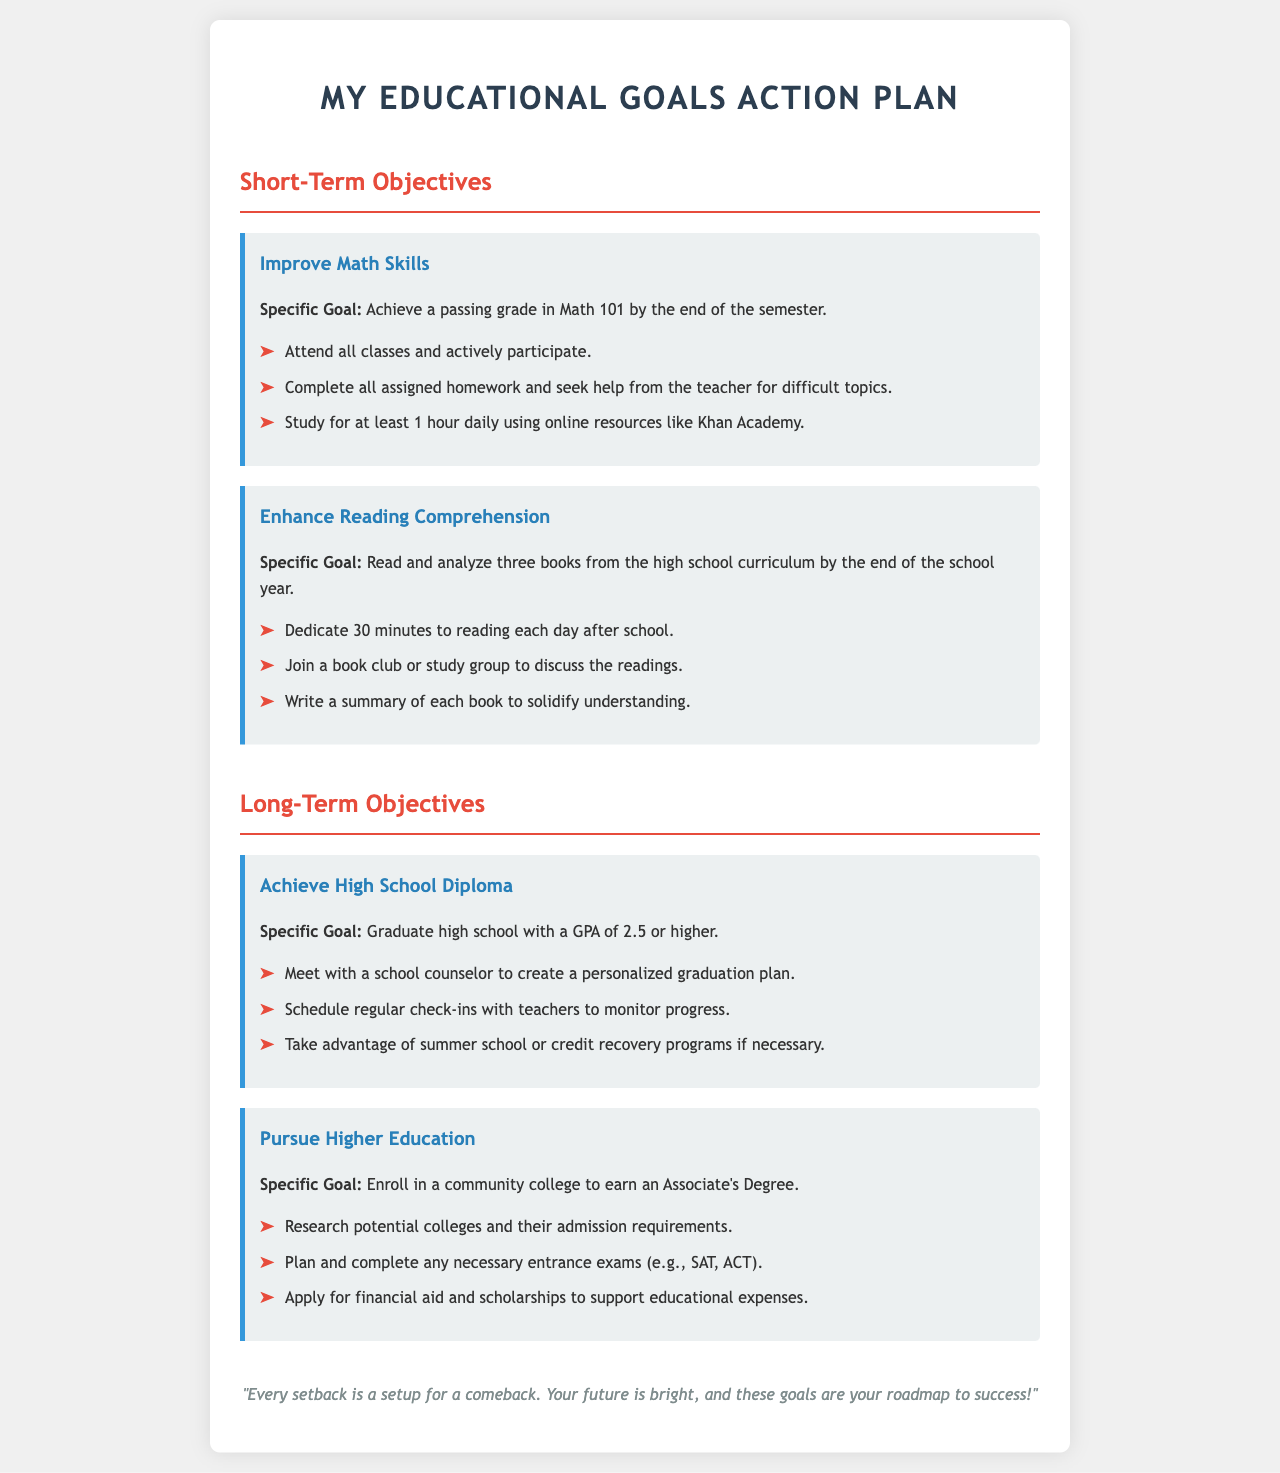What is the specific goal for improving math skills? The specific goal is to achieve a passing grade in Math 101 by the end of the semester.
Answer: Achieve a passing grade in Math 101 How many books are to be read for enhancing reading comprehension? The document states that three books from the high school curriculum should be read and analyzed.
Answer: Three books What is the GPA goal for graduating high school? The specific goal for graduating high school is to have a GPA of 2.5 or higher.
Answer: 2.5 or higher What are the daily study hours recommended for improving math skills? The document suggests studying for at least 1 hour daily using online resources.
Answer: 1 hour Which educational level is the focus of pursuing higher education? The specific goal is to enroll in a community college to earn an Associate's Degree.
Answer: Associate's Degree What should be done after reading each book to solidify understanding? The document states that writing a summary of each book helps solidify understanding.
Answer: Write a summary What is one suggested action to monitor progress towards long-term academic objectives? Regular check-ins with teachers are suggested to monitor progress.
Answer: Schedule regular check-ins What is the motivational quote found at the bottom of the plan? The motivational quote is "Every setback is a setup for a comeback."
Answer: "Every setback is a setup for a comeback." 